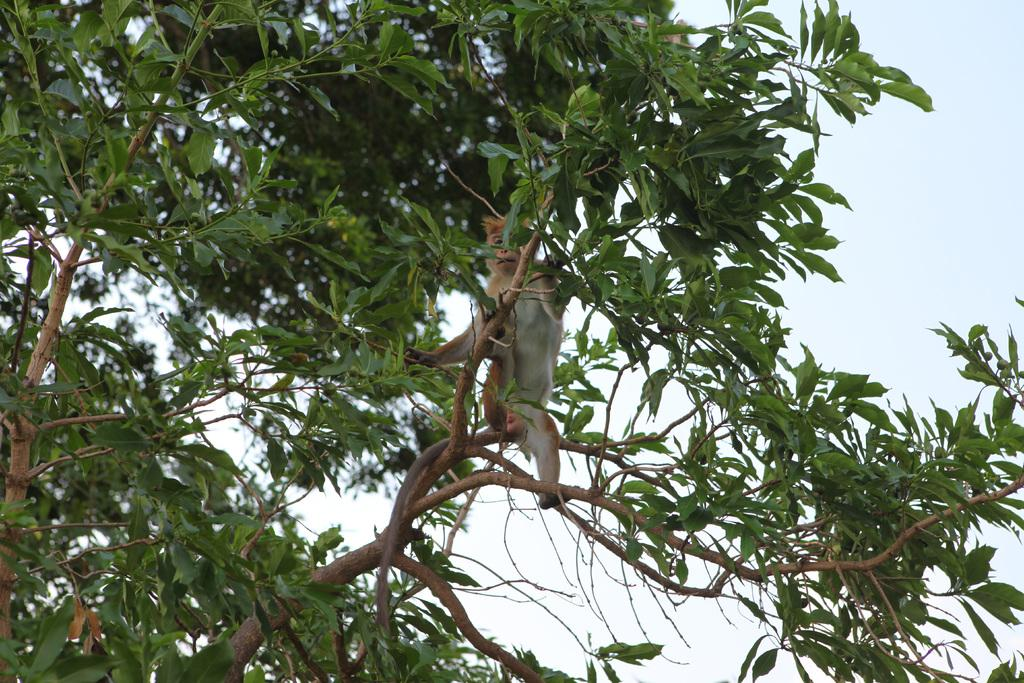What type of vegetation can be seen in the image? There are trees in the image. Is there any wildlife present in the image? Yes, there is a monkey on one of the trees. What can be seen in the background of the image? The sky is visible in the image. What is the price of the boats in the image? There are no boats present in the image, so it is not possible to determine their price. 